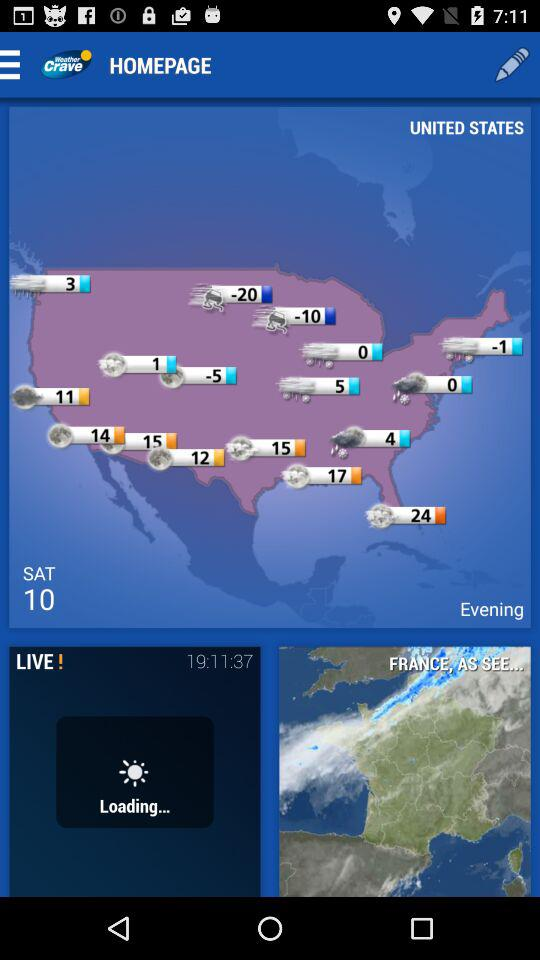Which day has been shown? The shown day is Saturday. 